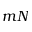<formula> <loc_0><loc_0><loc_500><loc_500>m N</formula> 